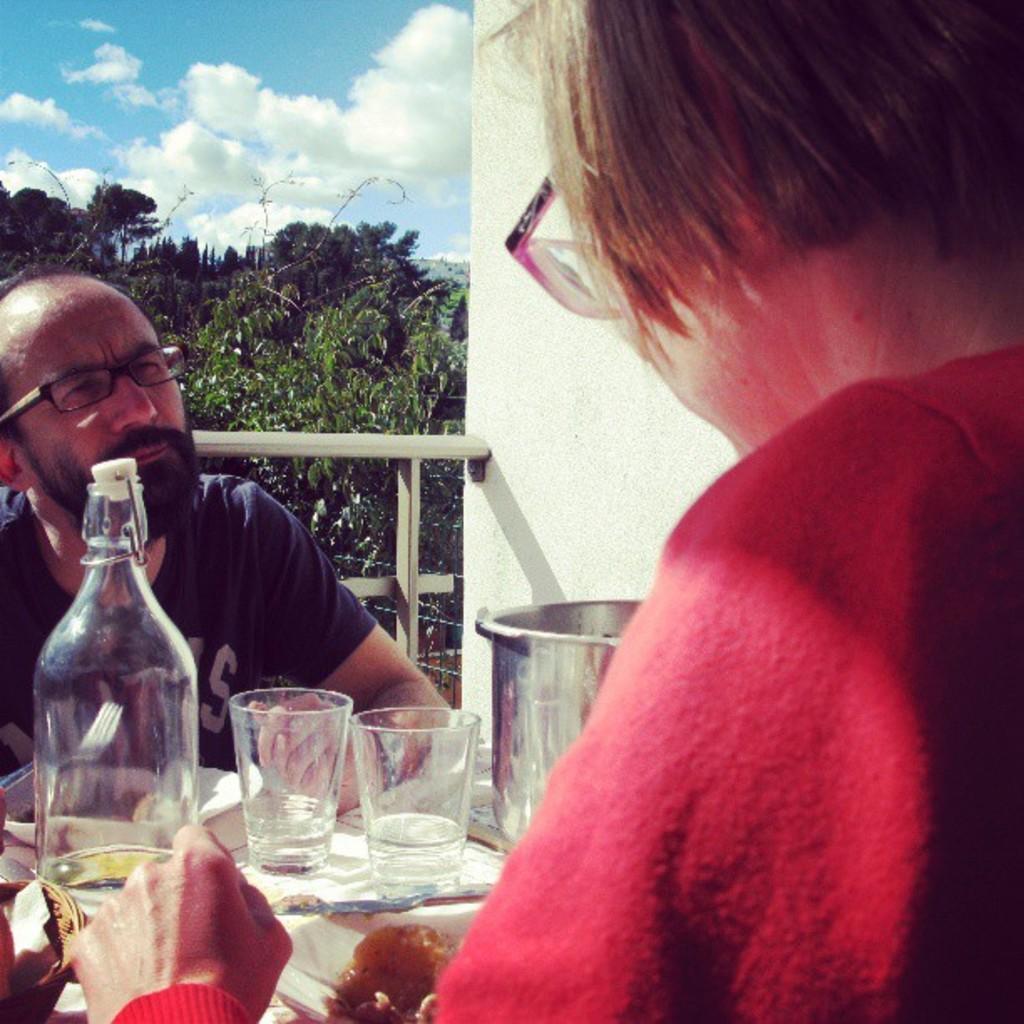Could you give a brief overview of what you see in this image? In this picture a man and woman sitting in front of a table with two water glasses and water bottle. The man is staring at the woman, there is also some food in the plate. 